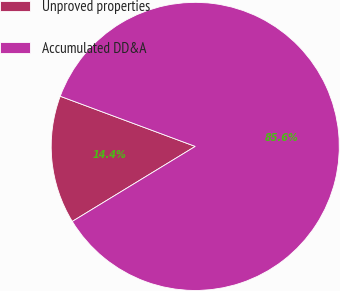<chart> <loc_0><loc_0><loc_500><loc_500><pie_chart><fcel>Unproved properties<fcel>Accumulated DD&A<nl><fcel>14.38%<fcel>85.62%<nl></chart> 